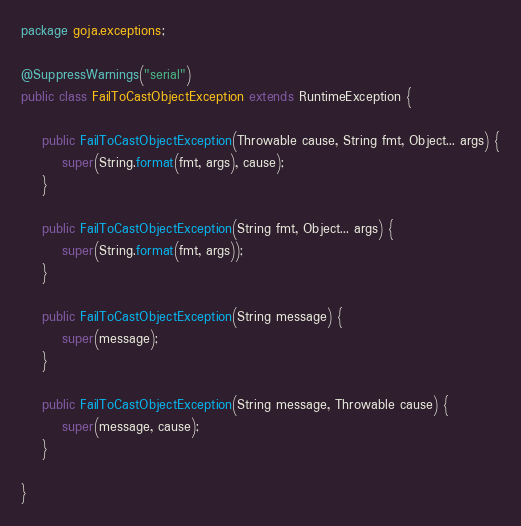Convert code to text. <code><loc_0><loc_0><loc_500><loc_500><_Java_>package goja.exceptions;

@SuppressWarnings("serial")
public class FailToCastObjectException extends RuntimeException {

    public FailToCastObjectException(Throwable cause, String fmt, Object... args) {
        super(String.format(fmt, args), cause);
    }

    public FailToCastObjectException(String fmt, Object... args) {
        super(String.format(fmt, args));
    }

    public FailToCastObjectException(String message) {
        super(message);
    }

    public FailToCastObjectException(String message, Throwable cause) {
        super(message, cause);
    }

}
</code> 